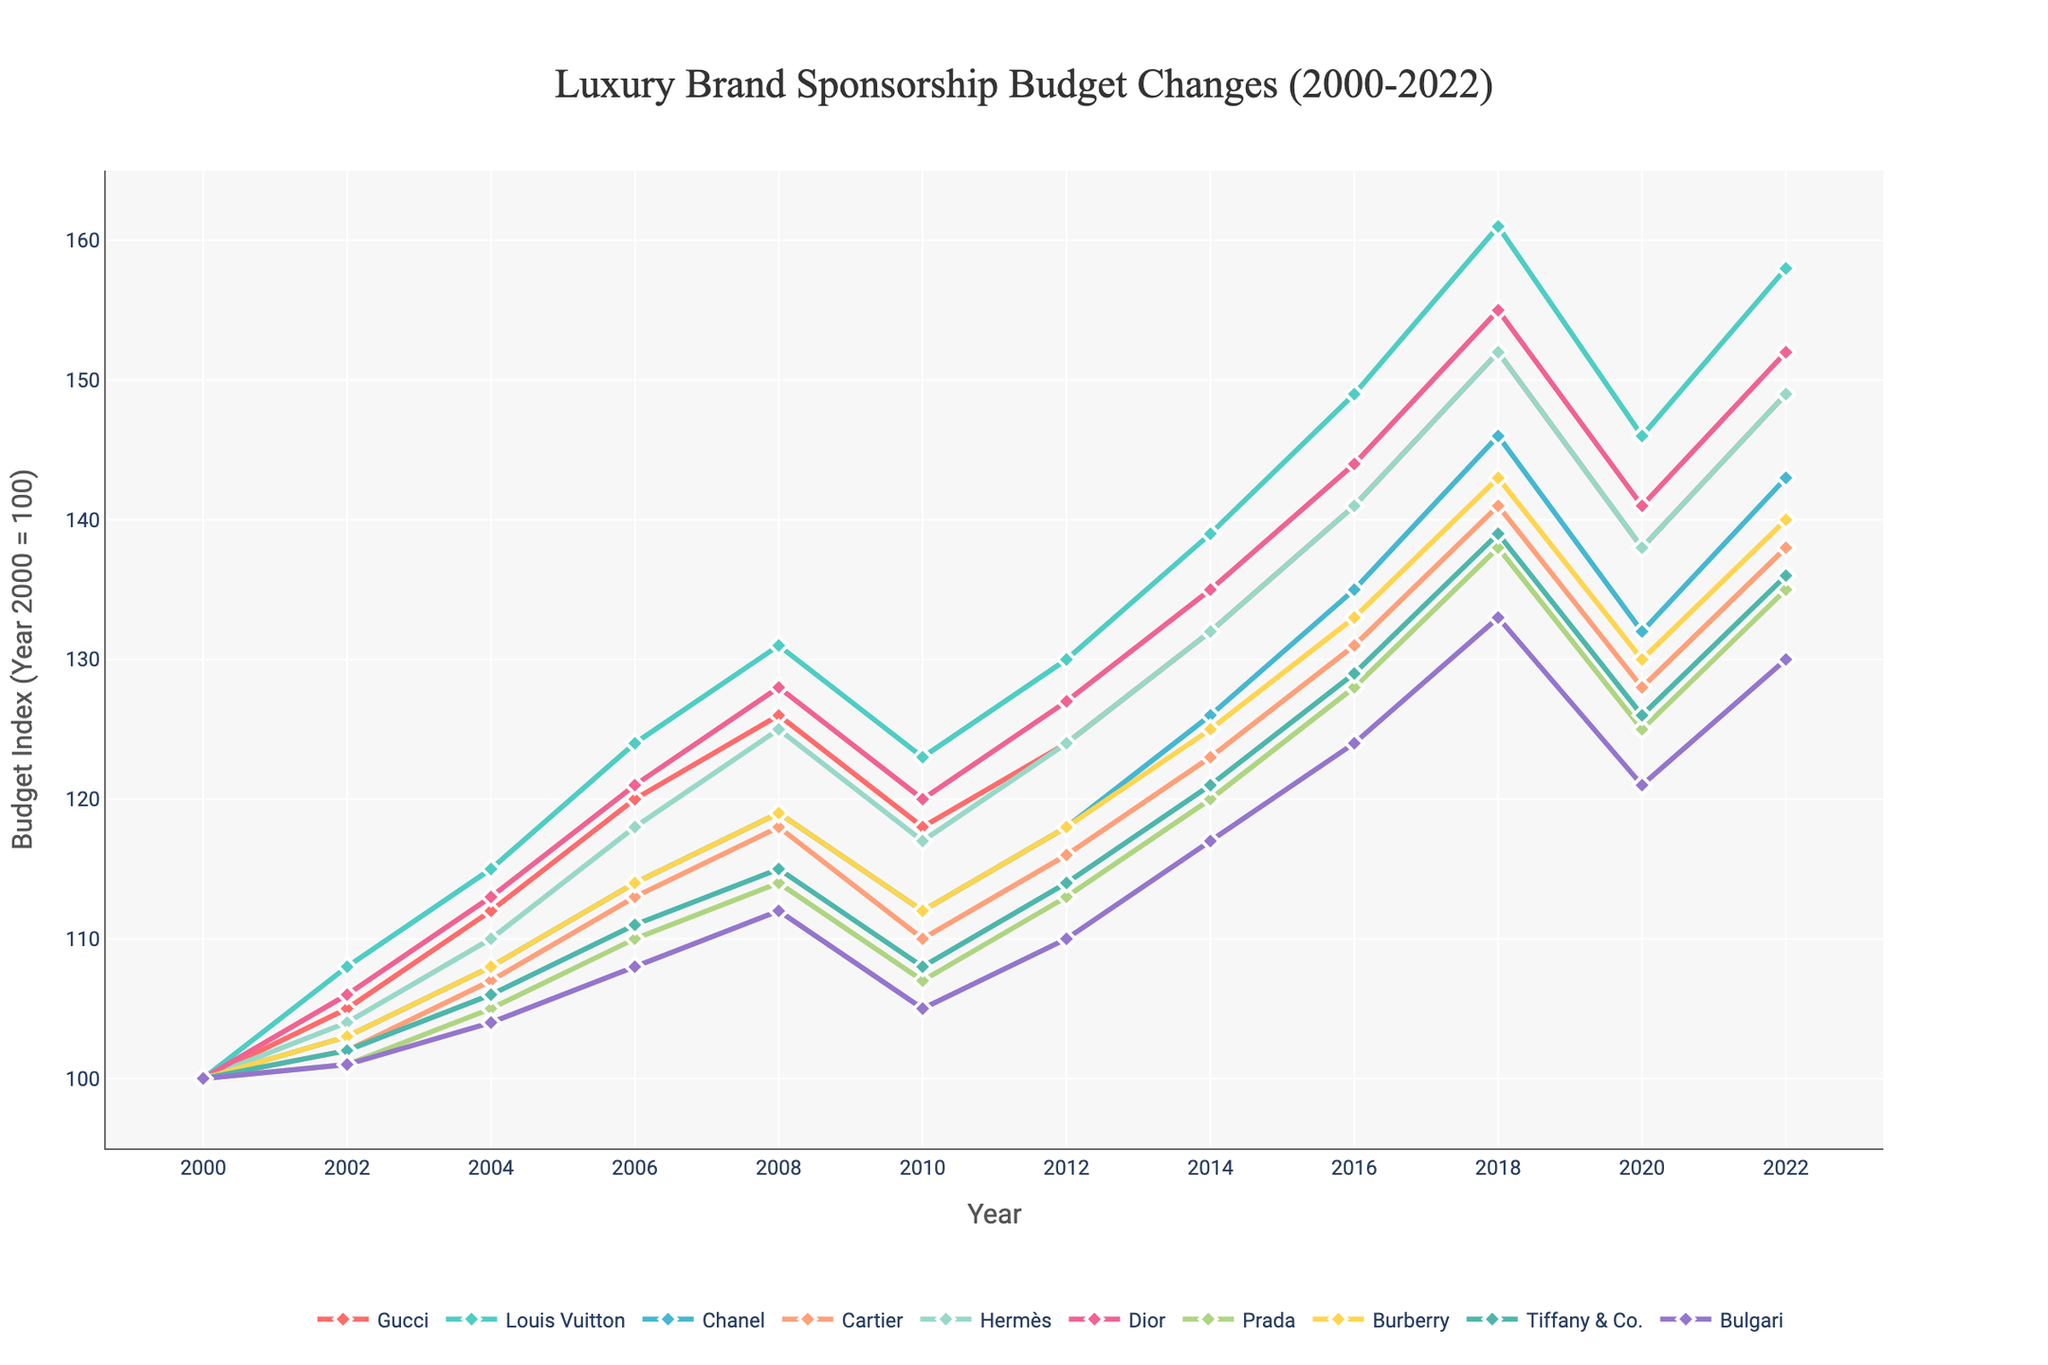Which brand had the highest sponsorship budget in 2022? To find the highest sponsorship budget in 2022, look for the brand's line that reaches the highest point on the y-axis in the year 2022. According to the plot, Louis Vuitton reached the highest point.
Answer: Louis Vuitton How did Cartier's budget change from 2010 to 2020? To find the change in Cartier's budget from 2010 to 2020, compare the y-values of Cartier's line at those two years. In 2010, it was 110, and in 2020 it was 128. The change is 128 - 110 = 18.
Answer: Increased by 18 Which years showed a decline in budgets for multiple brands? Look for dips in multiple lines around the same years. Both 2010 and 2020 displayed declines across several brands' lines.
Answer: 2010 and 2020 What is the average budget for Hermès across all recorded years? To compute the average, sum the budgets of Hermès for all years and divide by the total number of data points. Hermès budgets are 100, 104, 110, 118, 125, 117, 124, 132, 141, 152, 138, 149. Summing these gives 1510, and 1510 / 12 years = 125.83.
Answer: 125.83 Which brand had the least fluctuations in sponsorship budgets over the years? Assess each brand's line for smoothness or less vertical change. Prada's line appears to be the smoothest with fewer fluctuations compared to others.
Answer: Prada In which year did Gucci, Louis Vuitton, and Chanel all show increases in their budgets? Trace the lines of Gucci, Louis Vuitton, and Chanel and find the year in which all three lines ascend. All three lines show an increase in the year 2018.
Answer: 2018 What was the difference between the highest and lowest budgets in 2014? Determine the highest and lowest y-axis values among all brands in the year 2014. The highest is Louis Vuitton (139), and the lowest is Bulgari (117). The difference is 139 - 117 = 22.
Answer: 22 How many brands had a budget index above 140 in 2018? Check all the lines in the year 2018 and count those above the y-value of 140. The brands are Gucci, Louis Vuitton, Chanel, Hermès, and Dior—making a total of 5 brands.
Answer: 5 Did any brand's budget decrease consistently over consecutive recorded years? Inspect the lines for any consistent downward trend over multiple time periods. There is no brand that shows a consistent decline over two or more consecutive recorded years.
Answer: No By how much did Burberry's budget increase from 2006 to 2018? Locate Burberry's line and compare its height in 2006 and 2018. In 2006, it was 114, and in 2018, it was 143. The increase is 143 - 114 = 29.
Answer: 29 